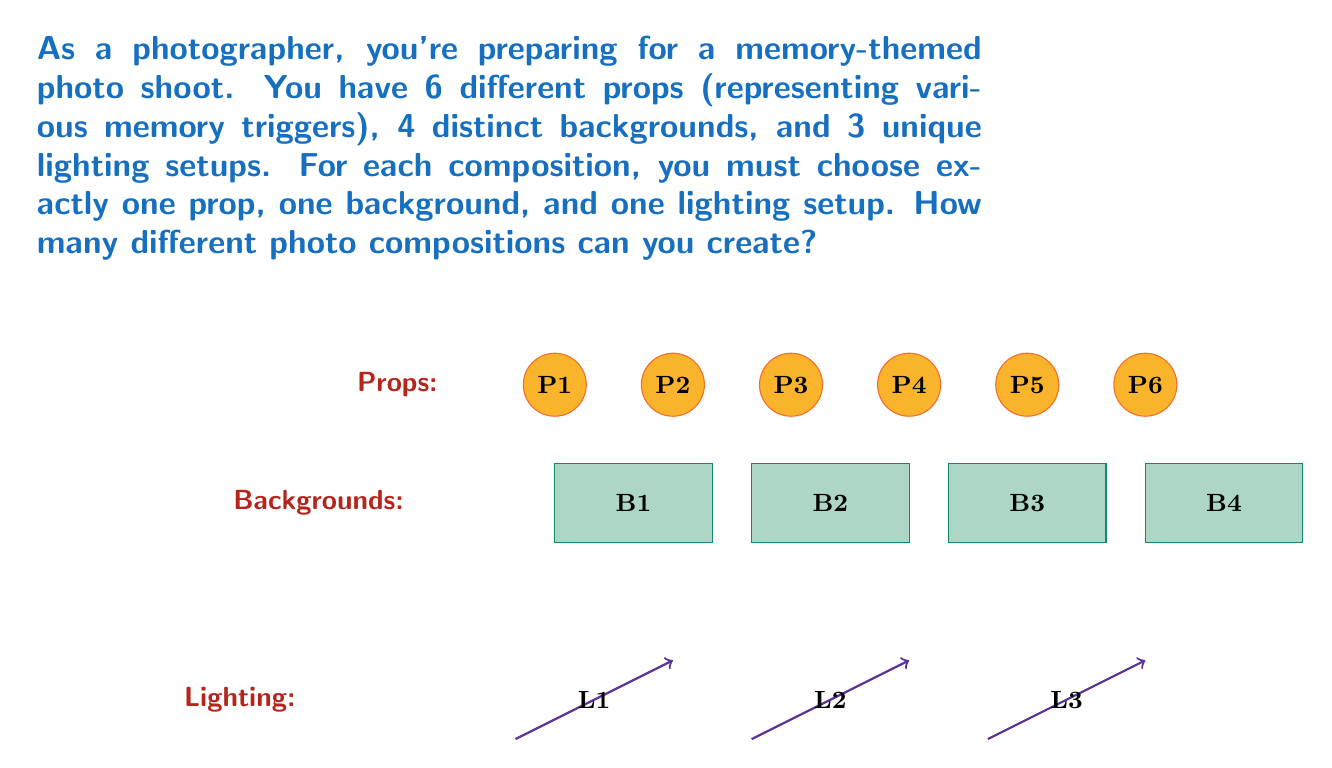Can you solve this math problem? To solve this problem, we'll use the multiplication principle of counting. This principle states that if we have a sequence of choices, and the number of options for each choice is independent of the other choices, then the total number of possible outcomes is the product of the number of options for each choice.

Let's break down the problem:

1. Props: We have 6 different props to choose from.
2. Backgrounds: We have 4 distinct backgrounds.
3. Lighting setups: We have 3 unique lighting setups.

For each composition, we must choose:
- Exactly one prop (6 options)
- Exactly one background (4 options)
- Exactly one lighting setup (3 options)

The choices are independent of each other, meaning the selection of a prop doesn't affect the available backgrounds or lighting setups, and so on.

Therefore, we can apply the multiplication principle:

Total number of compositions = (Number of props) × (Number of backgrounds) × (Number of lighting setups)

$$\text{Total compositions} = 6 \times 4 \times 3 = 72$$

This calculation gives us the total number of unique ways to combine one prop, one background, and one lighting setup.
Answer: 72 